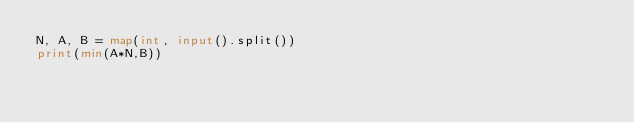<code> <loc_0><loc_0><loc_500><loc_500><_Python_>N, A, B = map(int, input().split())
print(min(A*N,B))</code> 